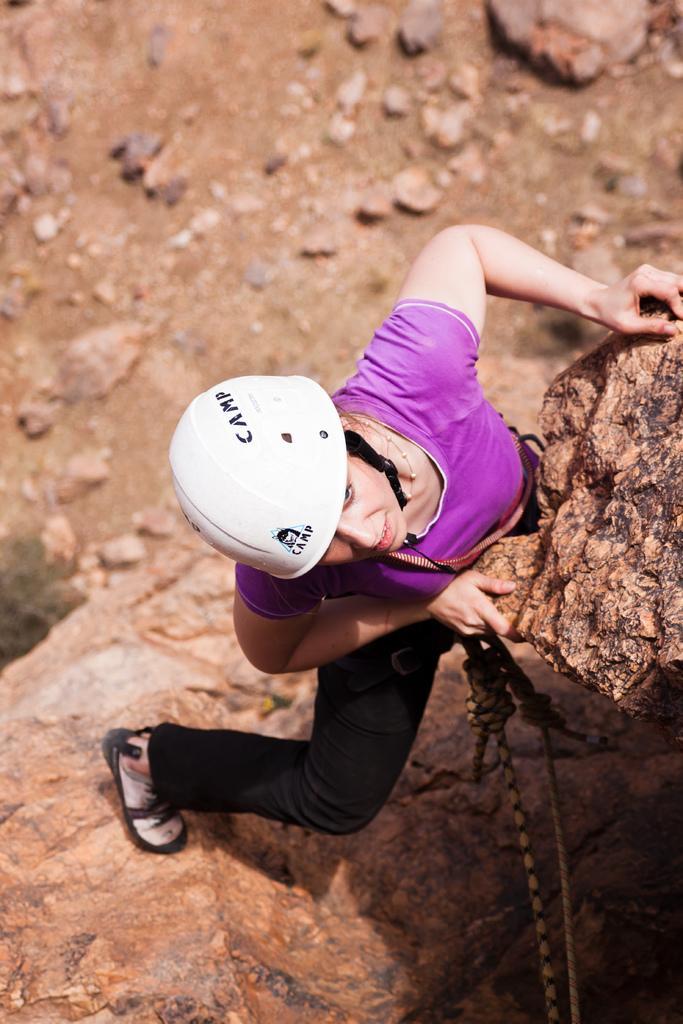Can you describe this image briefly? In this image we can see some big rocks and one woman wearing a white helmet with two wires sport climbing. 